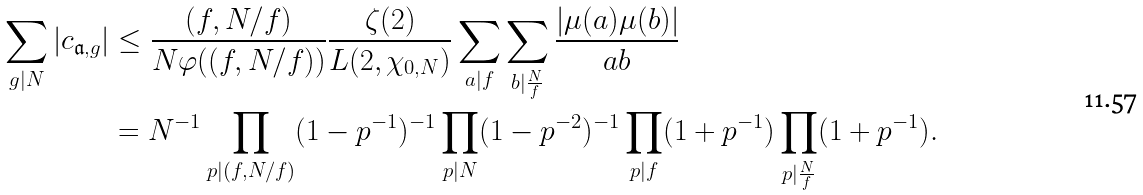<formula> <loc_0><loc_0><loc_500><loc_500>\sum _ { g | N } | c _ { \mathfrak { a } , g } | & \leq \frac { ( f , N / f ) } { N \varphi ( ( f , N / f ) ) } \frac { \zeta ( 2 ) } { L ( 2 , \chi _ { 0 , N } ) } \sum _ { a | f } \sum _ { b | \frac { N } { f } } \frac { | \mu ( a ) \mu ( b ) | } { a b } \\ & = N ^ { - 1 } \prod _ { p | ( f , N / f ) } ( 1 - p ^ { - 1 } ) ^ { - 1 } \prod _ { p | N } ( 1 - p ^ { - 2 } ) ^ { - 1 } \prod _ { p | f } ( 1 + p ^ { - 1 } ) \prod _ { p | \frac { N } { f } } ( 1 + p ^ { - 1 } ) .</formula> 